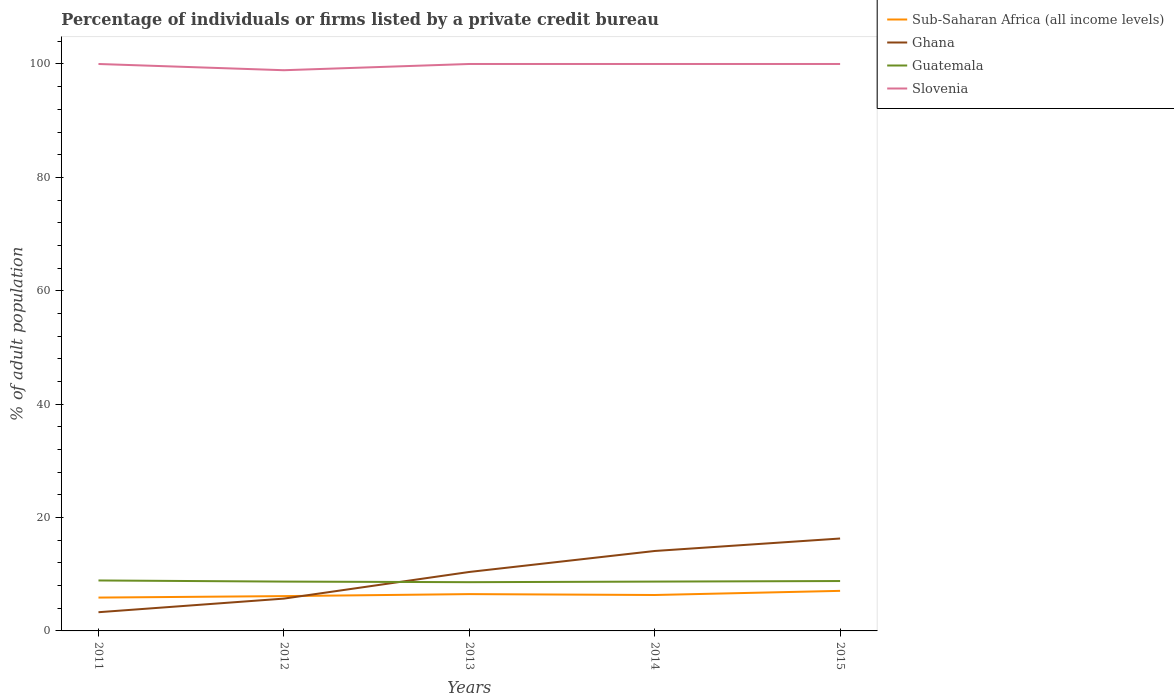How many different coloured lines are there?
Give a very brief answer. 4. Is the number of lines equal to the number of legend labels?
Make the answer very short. Yes. Across all years, what is the maximum percentage of population listed by a private credit bureau in Slovenia?
Give a very brief answer. 98.9. What is the total percentage of population listed by a private credit bureau in Guatemala in the graph?
Provide a short and direct response. -0.1. What is the difference between the highest and the second highest percentage of population listed by a private credit bureau in Sub-Saharan Africa (all income levels)?
Make the answer very short. 1.19. What is the difference between the highest and the lowest percentage of population listed by a private credit bureau in Slovenia?
Your answer should be very brief. 4. Is the percentage of population listed by a private credit bureau in Slovenia strictly greater than the percentage of population listed by a private credit bureau in Ghana over the years?
Your answer should be very brief. No. How many lines are there?
Offer a terse response. 4. What is the difference between two consecutive major ticks on the Y-axis?
Keep it short and to the point. 20. How many legend labels are there?
Your answer should be compact. 4. How are the legend labels stacked?
Provide a succinct answer. Vertical. What is the title of the graph?
Give a very brief answer. Percentage of individuals or firms listed by a private credit bureau. What is the label or title of the Y-axis?
Offer a very short reply. % of adult population. What is the % of adult population of Sub-Saharan Africa (all income levels) in 2011?
Give a very brief answer. 5.88. What is the % of adult population in Ghana in 2011?
Ensure brevity in your answer.  3.3. What is the % of adult population in Slovenia in 2011?
Give a very brief answer. 100. What is the % of adult population in Sub-Saharan Africa (all income levels) in 2012?
Offer a very short reply. 6.14. What is the % of adult population of Slovenia in 2012?
Make the answer very short. 98.9. What is the % of adult population of Sub-Saharan Africa (all income levels) in 2013?
Make the answer very short. 6.49. What is the % of adult population in Ghana in 2013?
Your answer should be very brief. 10.4. What is the % of adult population of Slovenia in 2013?
Offer a terse response. 100. What is the % of adult population of Sub-Saharan Africa (all income levels) in 2014?
Your response must be concise. 6.34. What is the % of adult population in Ghana in 2014?
Ensure brevity in your answer.  14.1. What is the % of adult population of Guatemala in 2014?
Provide a succinct answer. 8.7. What is the % of adult population in Sub-Saharan Africa (all income levels) in 2015?
Keep it short and to the point. 7.07. What is the % of adult population in Slovenia in 2015?
Offer a very short reply. 100. Across all years, what is the maximum % of adult population in Sub-Saharan Africa (all income levels)?
Provide a short and direct response. 7.07. Across all years, what is the maximum % of adult population of Slovenia?
Give a very brief answer. 100. Across all years, what is the minimum % of adult population in Sub-Saharan Africa (all income levels)?
Provide a short and direct response. 5.88. Across all years, what is the minimum % of adult population in Ghana?
Your response must be concise. 3.3. Across all years, what is the minimum % of adult population of Guatemala?
Provide a short and direct response. 8.6. Across all years, what is the minimum % of adult population of Slovenia?
Provide a short and direct response. 98.9. What is the total % of adult population of Sub-Saharan Africa (all income levels) in the graph?
Offer a very short reply. 31.92. What is the total % of adult population of Ghana in the graph?
Make the answer very short. 49.8. What is the total % of adult population in Guatemala in the graph?
Provide a short and direct response. 43.7. What is the total % of adult population of Slovenia in the graph?
Ensure brevity in your answer.  498.9. What is the difference between the % of adult population of Sub-Saharan Africa (all income levels) in 2011 and that in 2012?
Give a very brief answer. -0.26. What is the difference between the % of adult population in Ghana in 2011 and that in 2012?
Your response must be concise. -2.4. What is the difference between the % of adult population of Guatemala in 2011 and that in 2012?
Ensure brevity in your answer.  0.2. What is the difference between the % of adult population in Sub-Saharan Africa (all income levels) in 2011 and that in 2013?
Your response must be concise. -0.61. What is the difference between the % of adult population in Ghana in 2011 and that in 2013?
Your answer should be very brief. -7.1. What is the difference between the % of adult population of Guatemala in 2011 and that in 2013?
Your response must be concise. 0.3. What is the difference between the % of adult population of Sub-Saharan Africa (all income levels) in 2011 and that in 2014?
Give a very brief answer. -0.46. What is the difference between the % of adult population of Ghana in 2011 and that in 2014?
Keep it short and to the point. -10.8. What is the difference between the % of adult population in Sub-Saharan Africa (all income levels) in 2011 and that in 2015?
Give a very brief answer. -1.19. What is the difference between the % of adult population of Guatemala in 2011 and that in 2015?
Your answer should be very brief. 0.1. What is the difference between the % of adult population of Sub-Saharan Africa (all income levels) in 2012 and that in 2013?
Offer a very short reply. -0.35. What is the difference between the % of adult population in Guatemala in 2012 and that in 2013?
Make the answer very short. 0.1. What is the difference between the % of adult population of Slovenia in 2012 and that in 2013?
Keep it short and to the point. -1.1. What is the difference between the % of adult population of Sub-Saharan Africa (all income levels) in 2012 and that in 2014?
Provide a succinct answer. -0.2. What is the difference between the % of adult population of Guatemala in 2012 and that in 2014?
Your response must be concise. 0. What is the difference between the % of adult population in Sub-Saharan Africa (all income levels) in 2012 and that in 2015?
Give a very brief answer. -0.93. What is the difference between the % of adult population of Sub-Saharan Africa (all income levels) in 2013 and that in 2014?
Ensure brevity in your answer.  0.16. What is the difference between the % of adult population in Ghana in 2013 and that in 2014?
Your response must be concise. -3.7. What is the difference between the % of adult population in Sub-Saharan Africa (all income levels) in 2013 and that in 2015?
Your response must be concise. -0.57. What is the difference between the % of adult population of Ghana in 2013 and that in 2015?
Your response must be concise. -5.9. What is the difference between the % of adult population in Sub-Saharan Africa (all income levels) in 2014 and that in 2015?
Ensure brevity in your answer.  -0.73. What is the difference between the % of adult population of Guatemala in 2014 and that in 2015?
Make the answer very short. -0.1. What is the difference between the % of adult population in Sub-Saharan Africa (all income levels) in 2011 and the % of adult population in Ghana in 2012?
Your answer should be very brief. 0.18. What is the difference between the % of adult population in Sub-Saharan Africa (all income levels) in 2011 and the % of adult population in Guatemala in 2012?
Provide a short and direct response. -2.82. What is the difference between the % of adult population of Sub-Saharan Africa (all income levels) in 2011 and the % of adult population of Slovenia in 2012?
Your answer should be compact. -93.02. What is the difference between the % of adult population in Ghana in 2011 and the % of adult population in Slovenia in 2012?
Provide a succinct answer. -95.6. What is the difference between the % of adult population of Guatemala in 2011 and the % of adult population of Slovenia in 2012?
Provide a succinct answer. -90. What is the difference between the % of adult population in Sub-Saharan Africa (all income levels) in 2011 and the % of adult population in Ghana in 2013?
Your answer should be compact. -4.52. What is the difference between the % of adult population of Sub-Saharan Africa (all income levels) in 2011 and the % of adult population of Guatemala in 2013?
Offer a terse response. -2.72. What is the difference between the % of adult population in Sub-Saharan Africa (all income levels) in 2011 and the % of adult population in Slovenia in 2013?
Your response must be concise. -94.12. What is the difference between the % of adult population of Ghana in 2011 and the % of adult population of Slovenia in 2013?
Make the answer very short. -96.7. What is the difference between the % of adult population of Guatemala in 2011 and the % of adult population of Slovenia in 2013?
Your response must be concise. -91.1. What is the difference between the % of adult population in Sub-Saharan Africa (all income levels) in 2011 and the % of adult population in Ghana in 2014?
Your answer should be very brief. -8.22. What is the difference between the % of adult population in Sub-Saharan Africa (all income levels) in 2011 and the % of adult population in Guatemala in 2014?
Keep it short and to the point. -2.82. What is the difference between the % of adult population in Sub-Saharan Africa (all income levels) in 2011 and the % of adult population in Slovenia in 2014?
Provide a short and direct response. -94.12. What is the difference between the % of adult population of Ghana in 2011 and the % of adult population of Slovenia in 2014?
Your answer should be compact. -96.7. What is the difference between the % of adult population of Guatemala in 2011 and the % of adult population of Slovenia in 2014?
Make the answer very short. -91.1. What is the difference between the % of adult population of Sub-Saharan Africa (all income levels) in 2011 and the % of adult population of Ghana in 2015?
Your answer should be very brief. -10.42. What is the difference between the % of adult population of Sub-Saharan Africa (all income levels) in 2011 and the % of adult population of Guatemala in 2015?
Give a very brief answer. -2.92. What is the difference between the % of adult population of Sub-Saharan Africa (all income levels) in 2011 and the % of adult population of Slovenia in 2015?
Offer a terse response. -94.12. What is the difference between the % of adult population in Ghana in 2011 and the % of adult population in Slovenia in 2015?
Make the answer very short. -96.7. What is the difference between the % of adult population in Guatemala in 2011 and the % of adult population in Slovenia in 2015?
Your answer should be compact. -91.1. What is the difference between the % of adult population in Sub-Saharan Africa (all income levels) in 2012 and the % of adult population in Ghana in 2013?
Offer a terse response. -4.26. What is the difference between the % of adult population of Sub-Saharan Africa (all income levels) in 2012 and the % of adult population of Guatemala in 2013?
Keep it short and to the point. -2.46. What is the difference between the % of adult population in Sub-Saharan Africa (all income levels) in 2012 and the % of adult population in Slovenia in 2013?
Your answer should be very brief. -93.86. What is the difference between the % of adult population of Ghana in 2012 and the % of adult population of Slovenia in 2013?
Give a very brief answer. -94.3. What is the difference between the % of adult population of Guatemala in 2012 and the % of adult population of Slovenia in 2013?
Your answer should be compact. -91.3. What is the difference between the % of adult population of Sub-Saharan Africa (all income levels) in 2012 and the % of adult population of Ghana in 2014?
Provide a short and direct response. -7.96. What is the difference between the % of adult population of Sub-Saharan Africa (all income levels) in 2012 and the % of adult population of Guatemala in 2014?
Provide a short and direct response. -2.56. What is the difference between the % of adult population in Sub-Saharan Africa (all income levels) in 2012 and the % of adult population in Slovenia in 2014?
Offer a very short reply. -93.86. What is the difference between the % of adult population in Ghana in 2012 and the % of adult population in Guatemala in 2014?
Provide a succinct answer. -3. What is the difference between the % of adult population of Ghana in 2012 and the % of adult population of Slovenia in 2014?
Offer a very short reply. -94.3. What is the difference between the % of adult population in Guatemala in 2012 and the % of adult population in Slovenia in 2014?
Provide a succinct answer. -91.3. What is the difference between the % of adult population in Sub-Saharan Africa (all income levels) in 2012 and the % of adult population in Ghana in 2015?
Offer a terse response. -10.16. What is the difference between the % of adult population in Sub-Saharan Africa (all income levels) in 2012 and the % of adult population in Guatemala in 2015?
Make the answer very short. -2.66. What is the difference between the % of adult population of Sub-Saharan Africa (all income levels) in 2012 and the % of adult population of Slovenia in 2015?
Your response must be concise. -93.86. What is the difference between the % of adult population of Ghana in 2012 and the % of adult population of Guatemala in 2015?
Your answer should be compact. -3.1. What is the difference between the % of adult population of Ghana in 2012 and the % of adult population of Slovenia in 2015?
Make the answer very short. -94.3. What is the difference between the % of adult population in Guatemala in 2012 and the % of adult population in Slovenia in 2015?
Offer a very short reply. -91.3. What is the difference between the % of adult population in Sub-Saharan Africa (all income levels) in 2013 and the % of adult population in Ghana in 2014?
Provide a succinct answer. -7.61. What is the difference between the % of adult population in Sub-Saharan Africa (all income levels) in 2013 and the % of adult population in Guatemala in 2014?
Keep it short and to the point. -2.21. What is the difference between the % of adult population in Sub-Saharan Africa (all income levels) in 2013 and the % of adult population in Slovenia in 2014?
Keep it short and to the point. -93.51. What is the difference between the % of adult population in Ghana in 2013 and the % of adult population in Guatemala in 2014?
Make the answer very short. 1.7. What is the difference between the % of adult population in Ghana in 2013 and the % of adult population in Slovenia in 2014?
Ensure brevity in your answer.  -89.6. What is the difference between the % of adult population in Guatemala in 2013 and the % of adult population in Slovenia in 2014?
Keep it short and to the point. -91.4. What is the difference between the % of adult population in Sub-Saharan Africa (all income levels) in 2013 and the % of adult population in Ghana in 2015?
Provide a succinct answer. -9.81. What is the difference between the % of adult population in Sub-Saharan Africa (all income levels) in 2013 and the % of adult population in Guatemala in 2015?
Your response must be concise. -2.31. What is the difference between the % of adult population of Sub-Saharan Africa (all income levels) in 2013 and the % of adult population of Slovenia in 2015?
Provide a succinct answer. -93.51. What is the difference between the % of adult population in Ghana in 2013 and the % of adult population in Slovenia in 2015?
Your response must be concise. -89.6. What is the difference between the % of adult population of Guatemala in 2013 and the % of adult population of Slovenia in 2015?
Ensure brevity in your answer.  -91.4. What is the difference between the % of adult population of Sub-Saharan Africa (all income levels) in 2014 and the % of adult population of Ghana in 2015?
Give a very brief answer. -9.96. What is the difference between the % of adult population of Sub-Saharan Africa (all income levels) in 2014 and the % of adult population of Guatemala in 2015?
Your answer should be compact. -2.46. What is the difference between the % of adult population in Sub-Saharan Africa (all income levels) in 2014 and the % of adult population in Slovenia in 2015?
Your answer should be compact. -93.66. What is the difference between the % of adult population in Ghana in 2014 and the % of adult population in Guatemala in 2015?
Offer a very short reply. 5.3. What is the difference between the % of adult population in Ghana in 2014 and the % of adult population in Slovenia in 2015?
Ensure brevity in your answer.  -85.9. What is the difference between the % of adult population in Guatemala in 2014 and the % of adult population in Slovenia in 2015?
Provide a short and direct response. -91.3. What is the average % of adult population in Sub-Saharan Africa (all income levels) per year?
Keep it short and to the point. 6.38. What is the average % of adult population in Ghana per year?
Make the answer very short. 9.96. What is the average % of adult population in Guatemala per year?
Ensure brevity in your answer.  8.74. What is the average % of adult population in Slovenia per year?
Your response must be concise. 99.78. In the year 2011, what is the difference between the % of adult population of Sub-Saharan Africa (all income levels) and % of adult population of Ghana?
Give a very brief answer. 2.58. In the year 2011, what is the difference between the % of adult population of Sub-Saharan Africa (all income levels) and % of adult population of Guatemala?
Your answer should be very brief. -3.02. In the year 2011, what is the difference between the % of adult population of Sub-Saharan Africa (all income levels) and % of adult population of Slovenia?
Offer a very short reply. -94.12. In the year 2011, what is the difference between the % of adult population in Ghana and % of adult population in Guatemala?
Give a very brief answer. -5.6. In the year 2011, what is the difference between the % of adult population in Ghana and % of adult population in Slovenia?
Make the answer very short. -96.7. In the year 2011, what is the difference between the % of adult population in Guatemala and % of adult population in Slovenia?
Offer a terse response. -91.1. In the year 2012, what is the difference between the % of adult population of Sub-Saharan Africa (all income levels) and % of adult population of Ghana?
Offer a terse response. 0.44. In the year 2012, what is the difference between the % of adult population of Sub-Saharan Africa (all income levels) and % of adult population of Guatemala?
Give a very brief answer. -2.56. In the year 2012, what is the difference between the % of adult population in Sub-Saharan Africa (all income levels) and % of adult population in Slovenia?
Provide a succinct answer. -92.76. In the year 2012, what is the difference between the % of adult population of Ghana and % of adult population of Guatemala?
Keep it short and to the point. -3. In the year 2012, what is the difference between the % of adult population in Ghana and % of adult population in Slovenia?
Your answer should be compact. -93.2. In the year 2012, what is the difference between the % of adult population of Guatemala and % of adult population of Slovenia?
Make the answer very short. -90.2. In the year 2013, what is the difference between the % of adult population in Sub-Saharan Africa (all income levels) and % of adult population in Ghana?
Offer a very short reply. -3.91. In the year 2013, what is the difference between the % of adult population of Sub-Saharan Africa (all income levels) and % of adult population of Guatemala?
Your response must be concise. -2.11. In the year 2013, what is the difference between the % of adult population of Sub-Saharan Africa (all income levels) and % of adult population of Slovenia?
Your response must be concise. -93.51. In the year 2013, what is the difference between the % of adult population of Ghana and % of adult population of Guatemala?
Provide a succinct answer. 1.8. In the year 2013, what is the difference between the % of adult population of Ghana and % of adult population of Slovenia?
Offer a very short reply. -89.6. In the year 2013, what is the difference between the % of adult population of Guatemala and % of adult population of Slovenia?
Your response must be concise. -91.4. In the year 2014, what is the difference between the % of adult population in Sub-Saharan Africa (all income levels) and % of adult population in Ghana?
Give a very brief answer. -7.76. In the year 2014, what is the difference between the % of adult population of Sub-Saharan Africa (all income levels) and % of adult population of Guatemala?
Your answer should be compact. -2.36. In the year 2014, what is the difference between the % of adult population of Sub-Saharan Africa (all income levels) and % of adult population of Slovenia?
Your answer should be compact. -93.66. In the year 2014, what is the difference between the % of adult population of Ghana and % of adult population of Guatemala?
Your answer should be compact. 5.4. In the year 2014, what is the difference between the % of adult population of Ghana and % of adult population of Slovenia?
Your answer should be very brief. -85.9. In the year 2014, what is the difference between the % of adult population in Guatemala and % of adult population in Slovenia?
Your response must be concise. -91.3. In the year 2015, what is the difference between the % of adult population of Sub-Saharan Africa (all income levels) and % of adult population of Ghana?
Provide a short and direct response. -9.23. In the year 2015, what is the difference between the % of adult population of Sub-Saharan Africa (all income levels) and % of adult population of Guatemala?
Your answer should be compact. -1.73. In the year 2015, what is the difference between the % of adult population of Sub-Saharan Africa (all income levels) and % of adult population of Slovenia?
Your response must be concise. -92.93. In the year 2015, what is the difference between the % of adult population in Ghana and % of adult population in Guatemala?
Provide a short and direct response. 7.5. In the year 2015, what is the difference between the % of adult population of Ghana and % of adult population of Slovenia?
Provide a short and direct response. -83.7. In the year 2015, what is the difference between the % of adult population of Guatemala and % of adult population of Slovenia?
Ensure brevity in your answer.  -91.2. What is the ratio of the % of adult population in Sub-Saharan Africa (all income levels) in 2011 to that in 2012?
Keep it short and to the point. 0.96. What is the ratio of the % of adult population in Ghana in 2011 to that in 2012?
Your answer should be compact. 0.58. What is the ratio of the % of adult population of Slovenia in 2011 to that in 2012?
Your response must be concise. 1.01. What is the ratio of the % of adult population in Sub-Saharan Africa (all income levels) in 2011 to that in 2013?
Provide a succinct answer. 0.91. What is the ratio of the % of adult population of Ghana in 2011 to that in 2013?
Provide a succinct answer. 0.32. What is the ratio of the % of adult population in Guatemala in 2011 to that in 2013?
Provide a short and direct response. 1.03. What is the ratio of the % of adult population of Slovenia in 2011 to that in 2013?
Your response must be concise. 1. What is the ratio of the % of adult population in Sub-Saharan Africa (all income levels) in 2011 to that in 2014?
Offer a terse response. 0.93. What is the ratio of the % of adult population of Ghana in 2011 to that in 2014?
Provide a short and direct response. 0.23. What is the ratio of the % of adult population in Slovenia in 2011 to that in 2014?
Your answer should be compact. 1. What is the ratio of the % of adult population in Sub-Saharan Africa (all income levels) in 2011 to that in 2015?
Your response must be concise. 0.83. What is the ratio of the % of adult population in Ghana in 2011 to that in 2015?
Your response must be concise. 0.2. What is the ratio of the % of adult population in Guatemala in 2011 to that in 2015?
Offer a very short reply. 1.01. What is the ratio of the % of adult population of Slovenia in 2011 to that in 2015?
Your answer should be compact. 1. What is the ratio of the % of adult population in Sub-Saharan Africa (all income levels) in 2012 to that in 2013?
Offer a terse response. 0.95. What is the ratio of the % of adult population in Ghana in 2012 to that in 2013?
Offer a very short reply. 0.55. What is the ratio of the % of adult population in Guatemala in 2012 to that in 2013?
Offer a very short reply. 1.01. What is the ratio of the % of adult population of Slovenia in 2012 to that in 2013?
Your answer should be very brief. 0.99. What is the ratio of the % of adult population in Sub-Saharan Africa (all income levels) in 2012 to that in 2014?
Make the answer very short. 0.97. What is the ratio of the % of adult population in Ghana in 2012 to that in 2014?
Your answer should be compact. 0.4. What is the ratio of the % of adult population of Guatemala in 2012 to that in 2014?
Give a very brief answer. 1. What is the ratio of the % of adult population of Sub-Saharan Africa (all income levels) in 2012 to that in 2015?
Offer a terse response. 0.87. What is the ratio of the % of adult population in Ghana in 2012 to that in 2015?
Your response must be concise. 0.35. What is the ratio of the % of adult population in Slovenia in 2012 to that in 2015?
Offer a very short reply. 0.99. What is the ratio of the % of adult population in Sub-Saharan Africa (all income levels) in 2013 to that in 2014?
Keep it short and to the point. 1.02. What is the ratio of the % of adult population of Ghana in 2013 to that in 2014?
Offer a very short reply. 0.74. What is the ratio of the % of adult population in Guatemala in 2013 to that in 2014?
Provide a succinct answer. 0.99. What is the ratio of the % of adult population of Sub-Saharan Africa (all income levels) in 2013 to that in 2015?
Your response must be concise. 0.92. What is the ratio of the % of adult population of Ghana in 2013 to that in 2015?
Offer a very short reply. 0.64. What is the ratio of the % of adult population of Guatemala in 2013 to that in 2015?
Your answer should be very brief. 0.98. What is the ratio of the % of adult population of Sub-Saharan Africa (all income levels) in 2014 to that in 2015?
Offer a very short reply. 0.9. What is the ratio of the % of adult population of Ghana in 2014 to that in 2015?
Ensure brevity in your answer.  0.86. What is the ratio of the % of adult population of Guatemala in 2014 to that in 2015?
Keep it short and to the point. 0.99. What is the difference between the highest and the second highest % of adult population of Sub-Saharan Africa (all income levels)?
Ensure brevity in your answer.  0.57. What is the difference between the highest and the lowest % of adult population in Sub-Saharan Africa (all income levels)?
Your answer should be very brief. 1.19. What is the difference between the highest and the lowest % of adult population of Guatemala?
Keep it short and to the point. 0.3. 